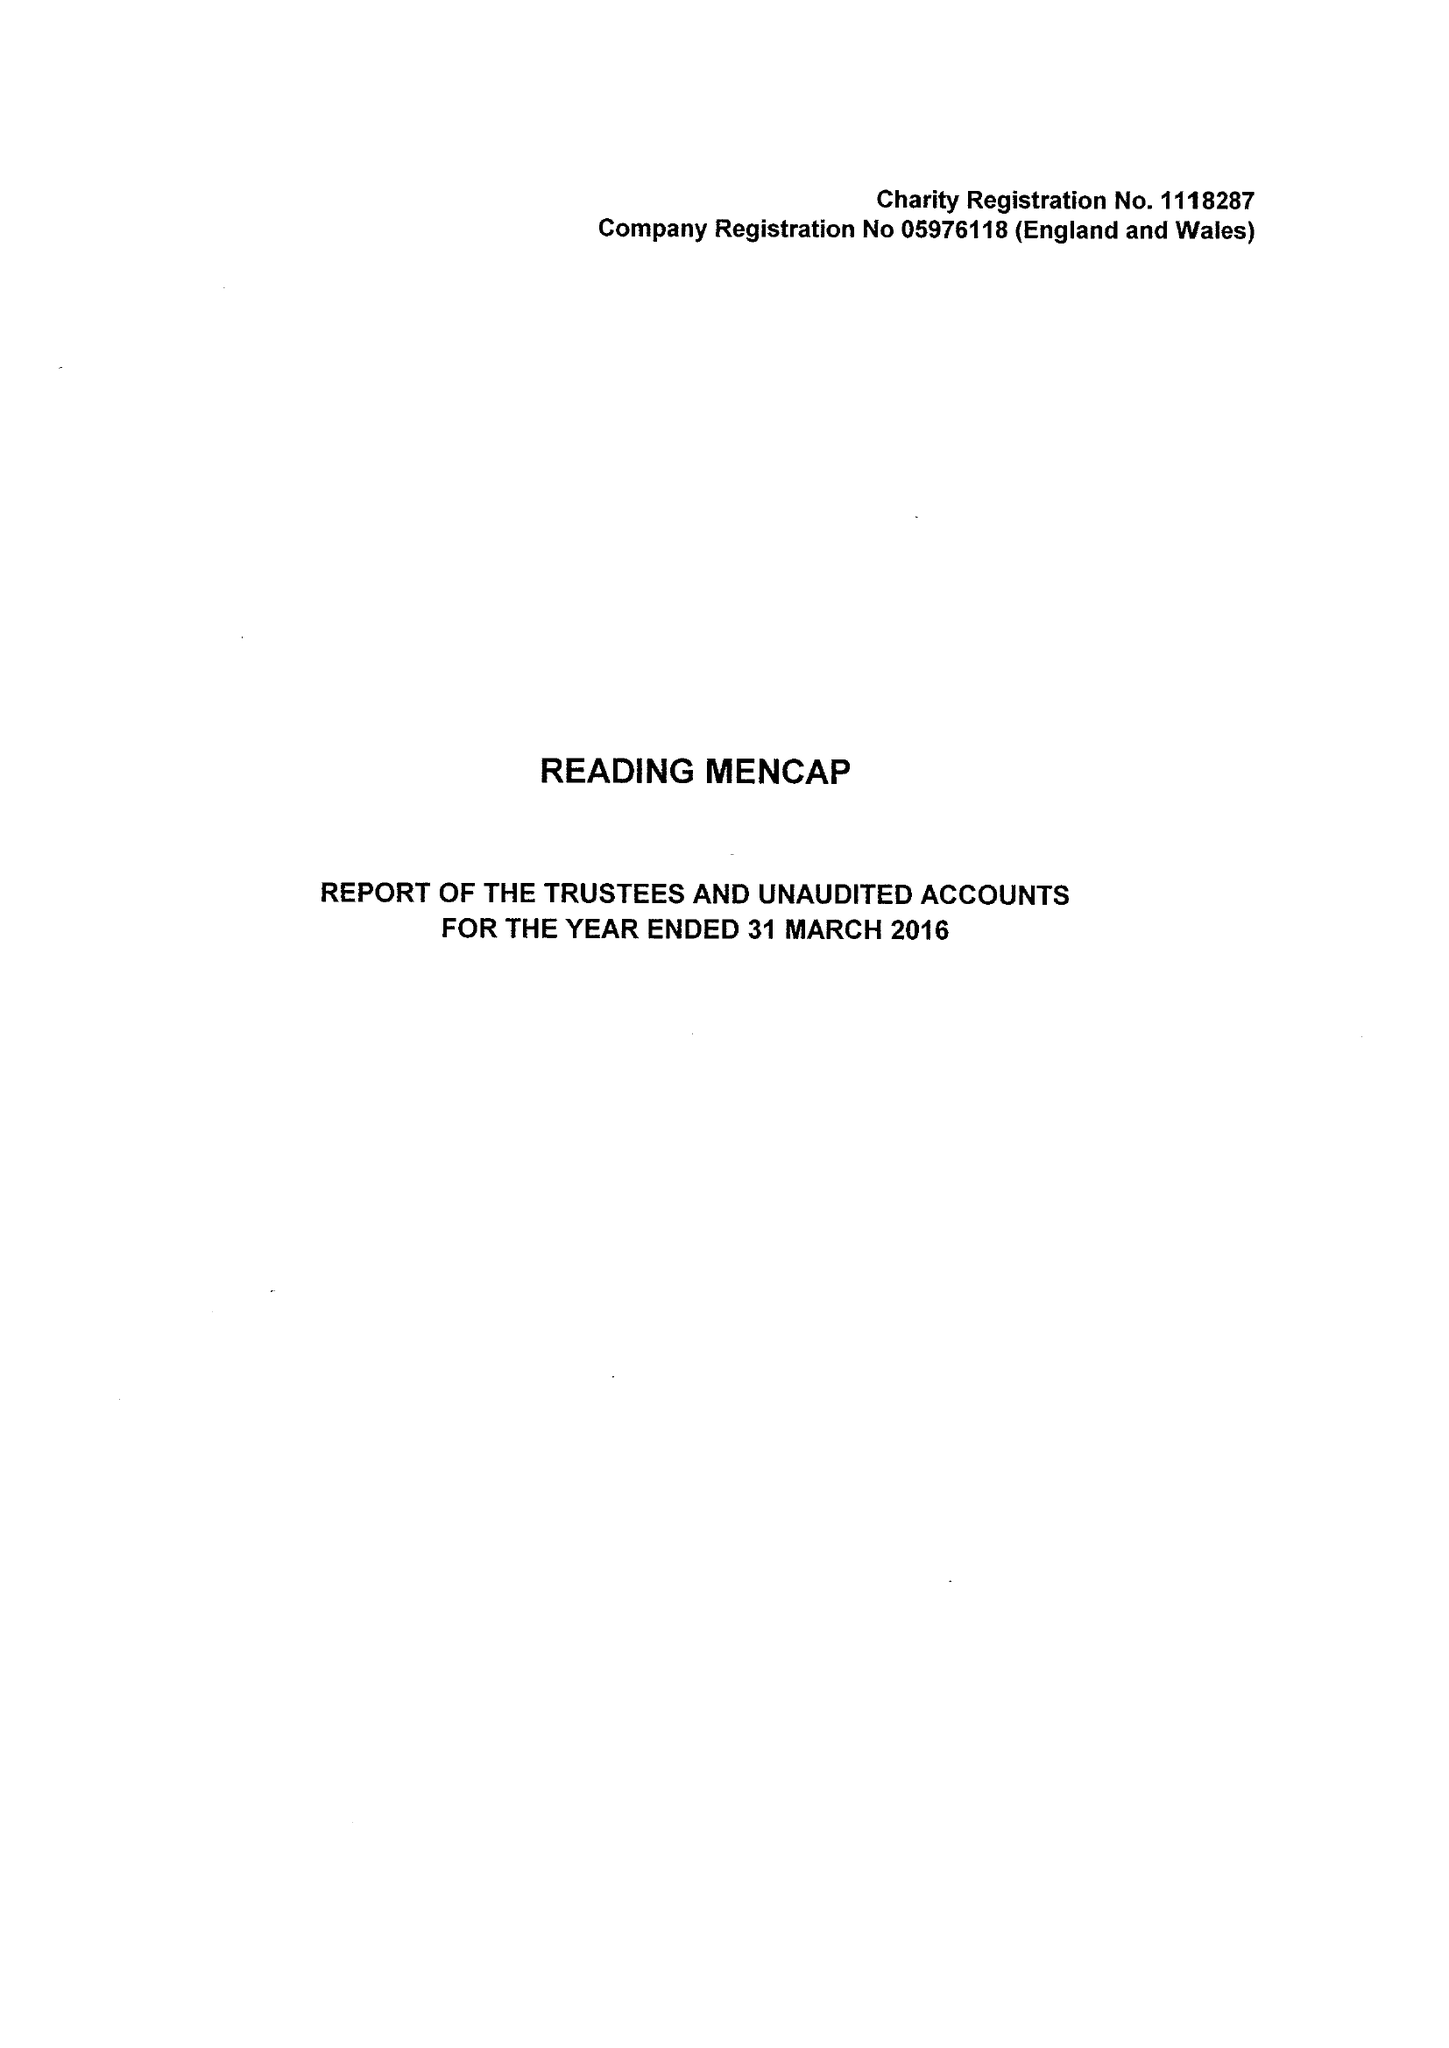What is the value for the address__postcode?
Answer the question using a single word or phrase. RG1 5PE 